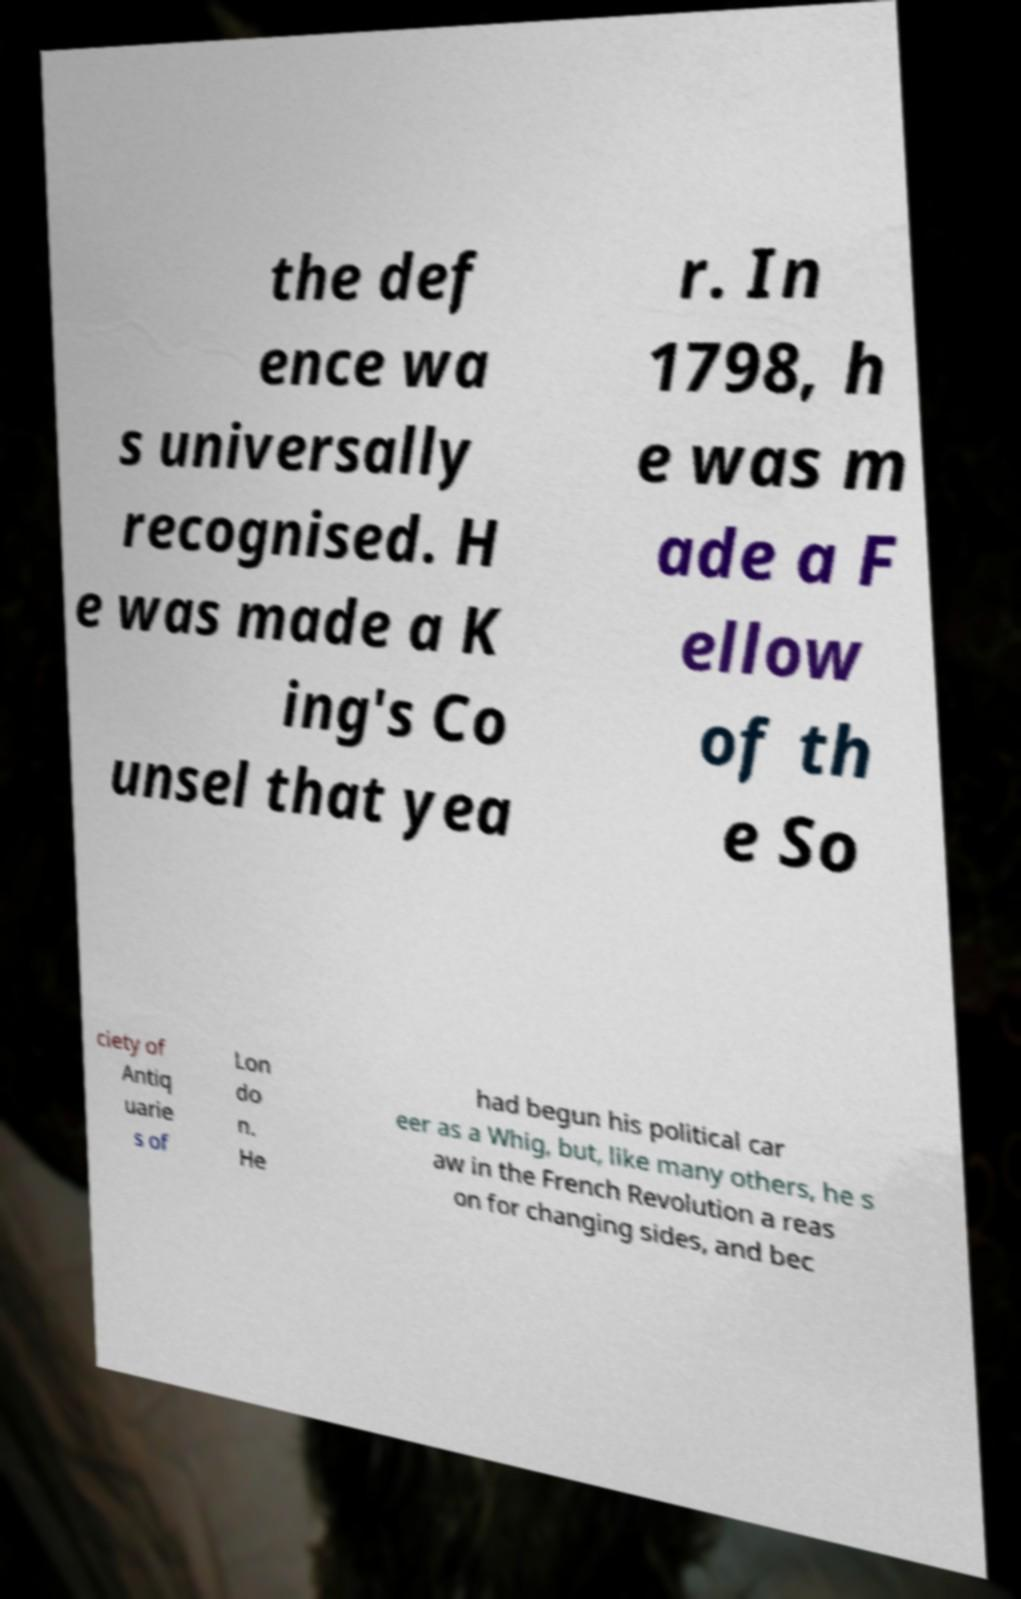Could you assist in decoding the text presented in this image and type it out clearly? the def ence wa s universally recognised. H e was made a K ing's Co unsel that yea r. In 1798, h e was m ade a F ellow of th e So ciety of Antiq uarie s of Lon do n. He had begun his political car eer as a Whig, but, like many others, he s aw in the French Revolution a reas on for changing sides, and bec 